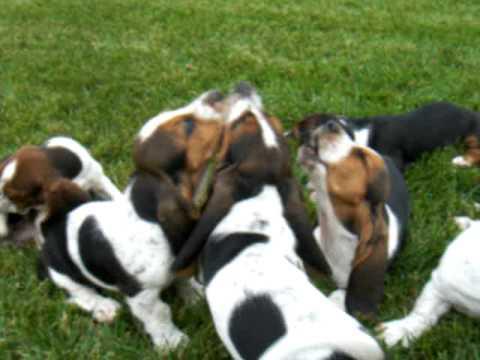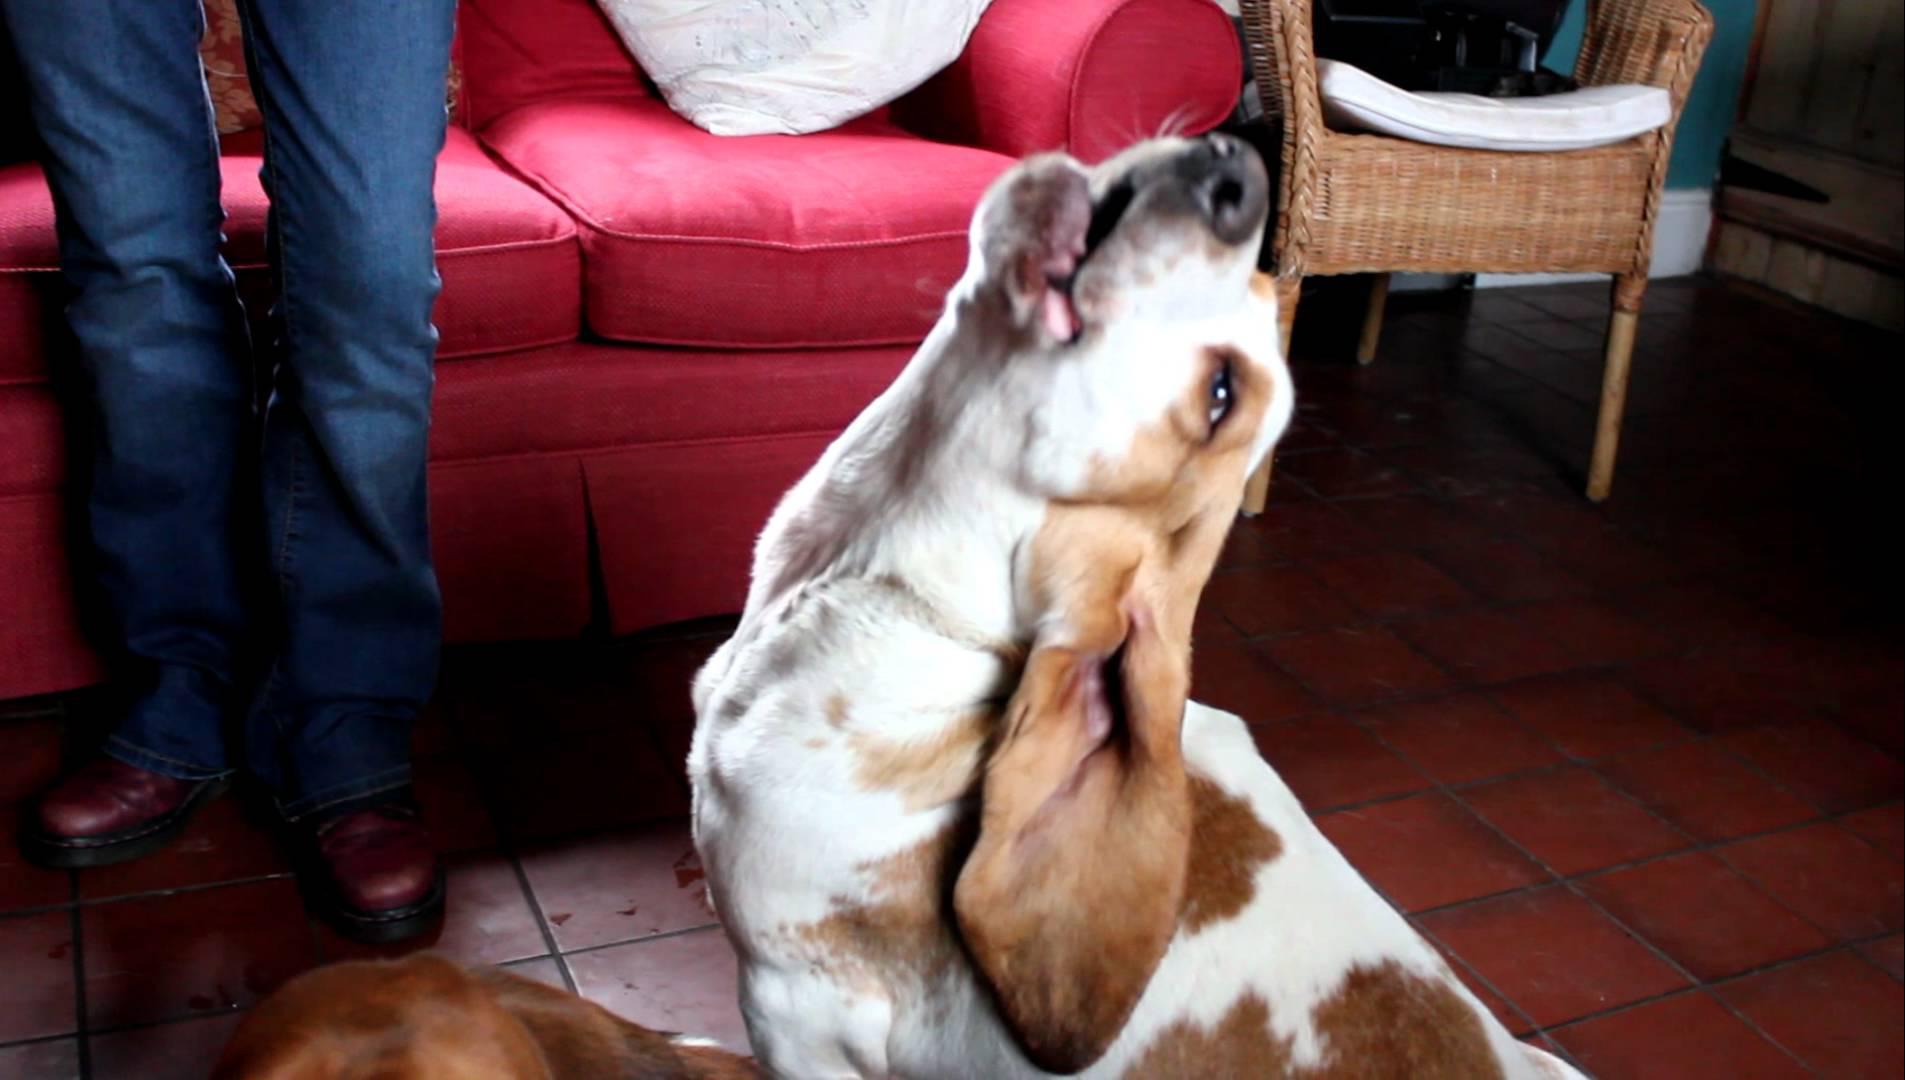The first image is the image on the left, the second image is the image on the right. For the images shown, is this caption "Each image contains exactly one basset hound, with one sitting and one standing." true? Answer yes or no. No. The first image is the image on the left, the second image is the image on the right. Assess this claim about the two images: "At least one of the dogs is sitting on the grass.". Correct or not? Answer yes or no. Yes. 